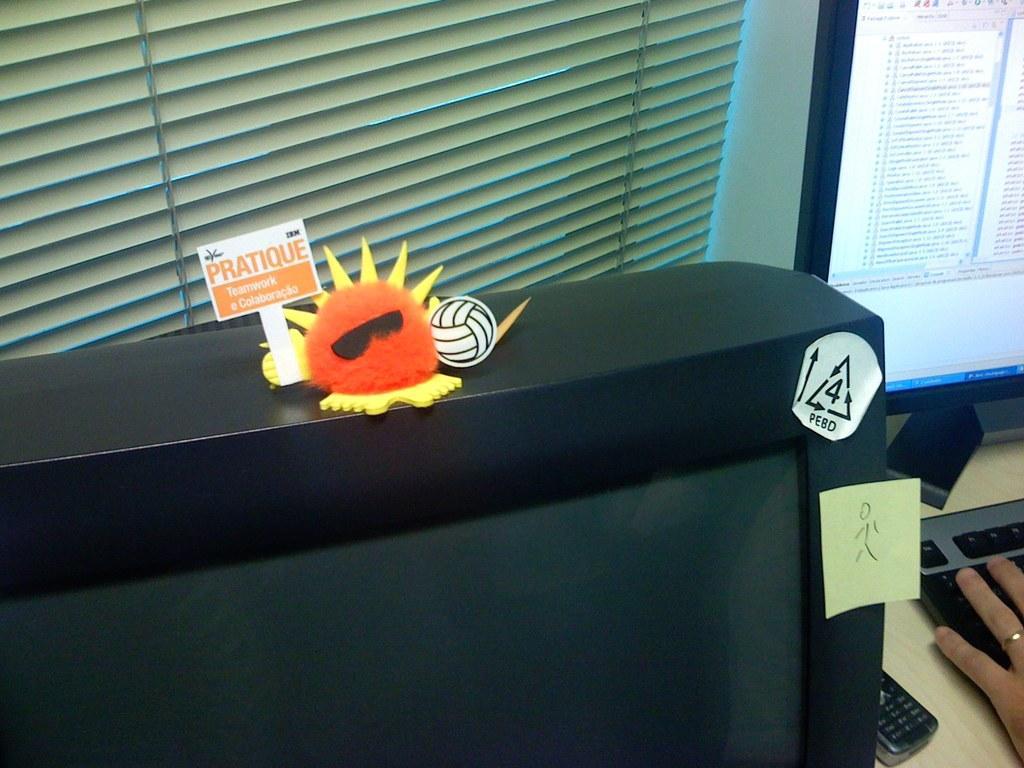Describe this image in one or two sentences. This picture shows a computer and a human hand and a mobile and we see a other monitor and a toy on it and we see blinds to the window 